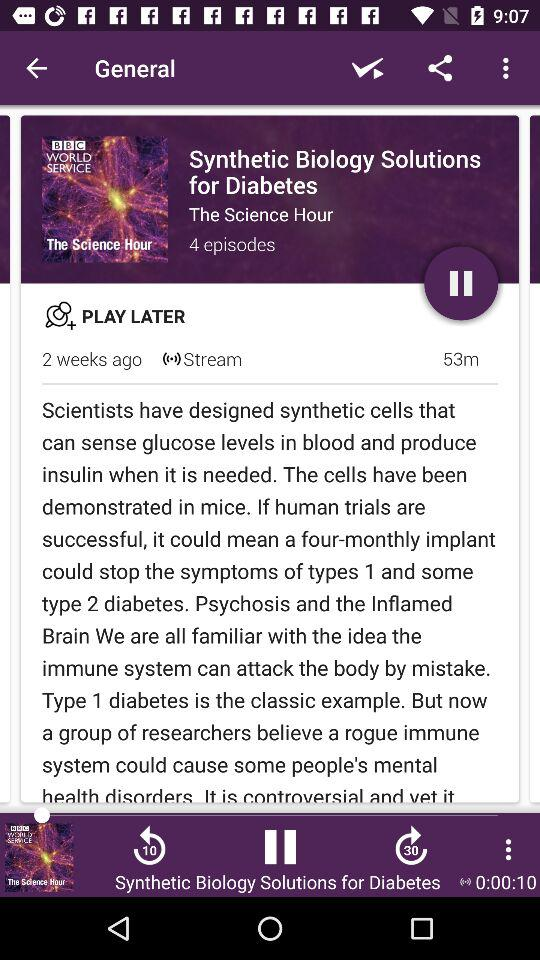Who might find this series informative? This series would be highly informative for medical professionals, researchers in the field of endocrinology and synthetic biology, as well as individuals affected by diabetes or those interested in the latest scientific advancements. 